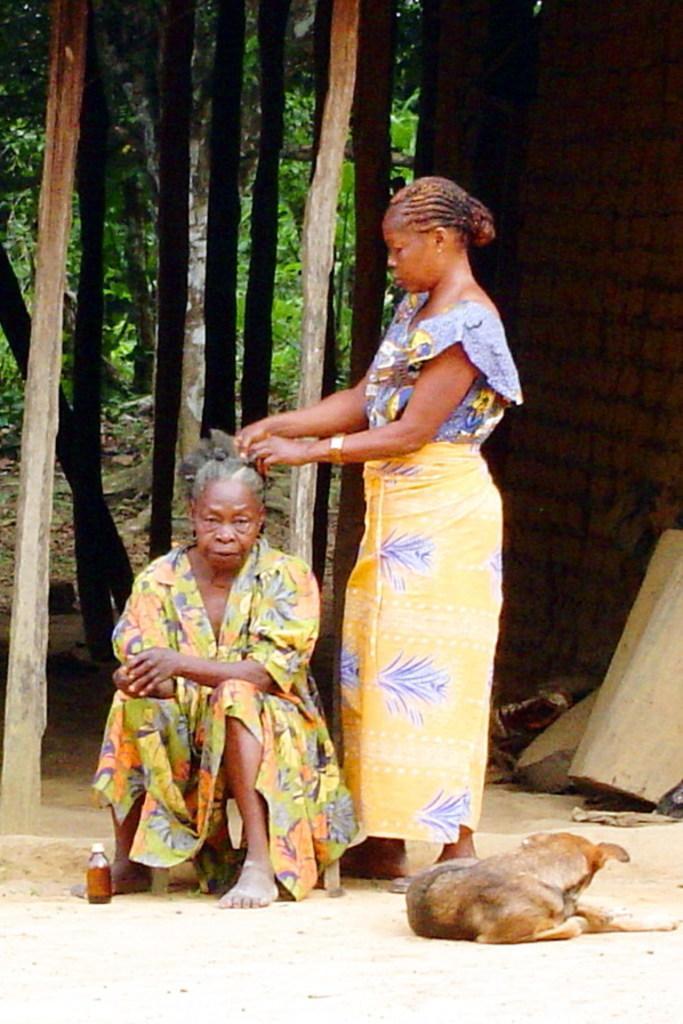Please provide a concise description of this image. In the foreground I can see two women's, a bottle and a dog is sitting on the road. In the background I can see bamboo sticks, a wall and trees. This image is taken during a day. 